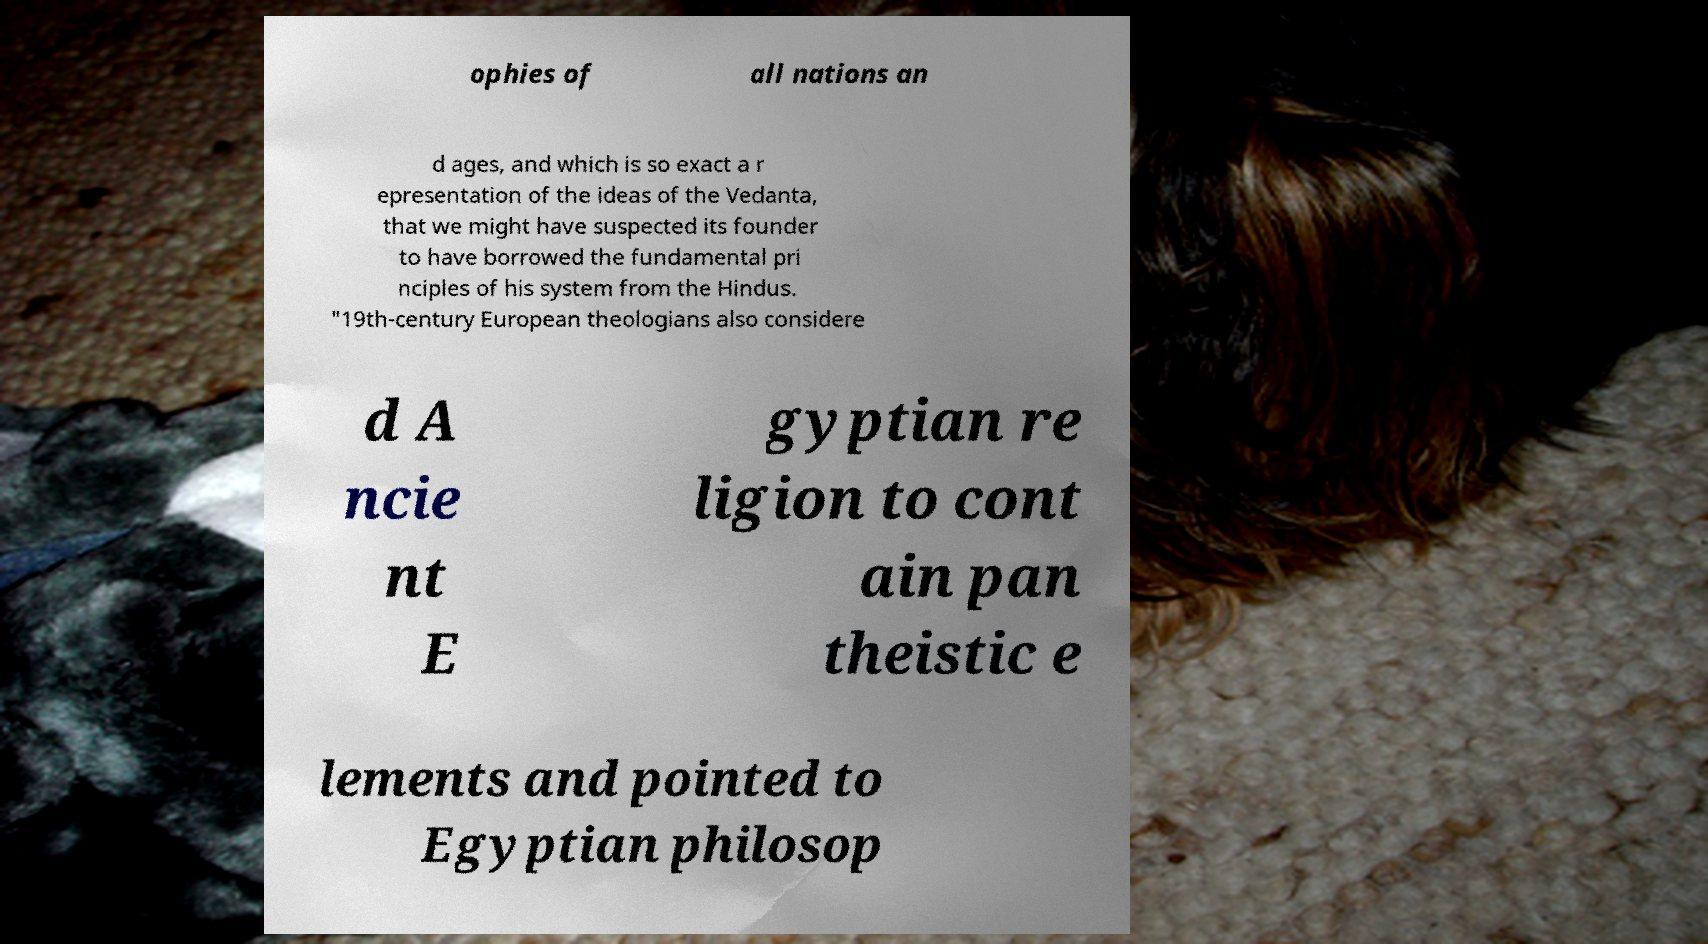I need the written content from this picture converted into text. Can you do that? ophies of all nations an d ages, and which is so exact a r epresentation of the ideas of the Vedanta, that we might have suspected its founder to have borrowed the fundamental pri nciples of his system from the Hindus. "19th-century European theologians also considere d A ncie nt E gyptian re ligion to cont ain pan theistic e lements and pointed to Egyptian philosop 